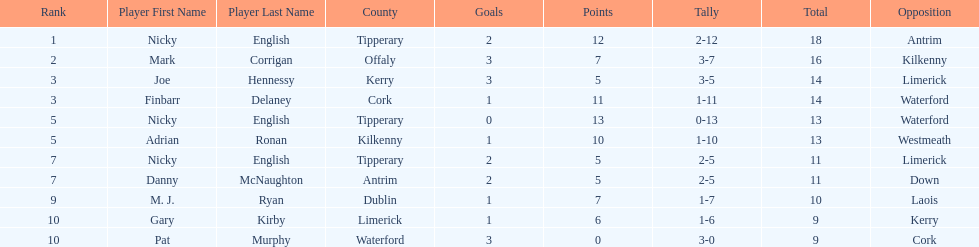Which player ranked the most? Nicky English. 